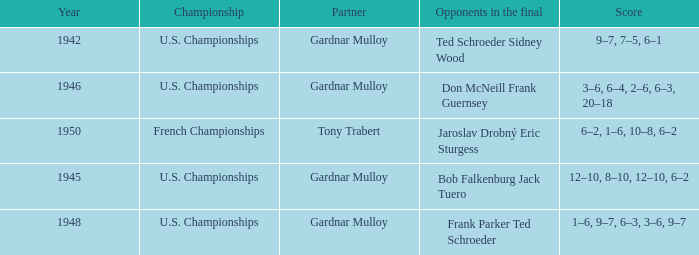I'm looking to parse the entire table for insights. Could you assist me with that? {'header': ['Year', 'Championship', 'Partner', 'Opponents in the final', 'Score'], 'rows': [['1942', 'U.S. Championships', 'Gardnar Mulloy', 'Ted Schroeder Sidney Wood', '9–7, 7–5, 6–1'], ['1946', 'U.S. Championships', 'Gardnar Mulloy', 'Don McNeill Frank Guernsey', '3–6, 6–4, 2–6, 6–3, 20–18'], ['1950', 'French Championships', 'Tony Trabert', 'Jaroslav Drobný Eric Sturgess', '6–2, 1–6, 10–8, 6–2'], ['1945', 'U.S. Championships', 'Gardnar Mulloy', 'Bob Falkenburg Jack Tuero', '12–10, 8–10, 12–10, 6–2'], ['1948', 'U.S. Championships', 'Gardnar Mulloy', 'Frank Parker Ted Schroeder', '1–6, 9–7, 6–3, 3–6, 9–7']]} What is the most recent year gardnar mulloy played as a partner and score was 12–10, 8–10, 12–10, 6–2? 1945.0. 